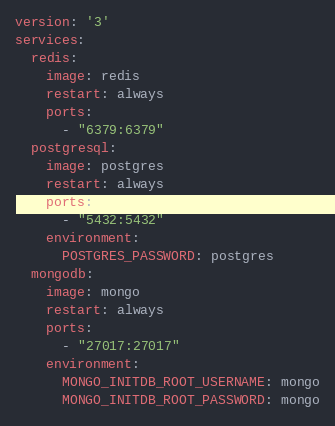<code> <loc_0><loc_0><loc_500><loc_500><_YAML_>version: '3'
services:
  redis:
    image: redis
    restart: always
    ports:
      - "6379:6379"
  postgresql:
    image: postgres
    restart: always
    ports:
      - "5432:5432"
    environment:
      POSTGRES_PASSWORD: postgres
  mongodb:
    image: mongo
    restart: always
    ports:
      - "27017:27017"
    environment:
      MONGO_INITDB_ROOT_USERNAME: mongo
      MONGO_INITDB_ROOT_PASSWORD: mongo</code> 